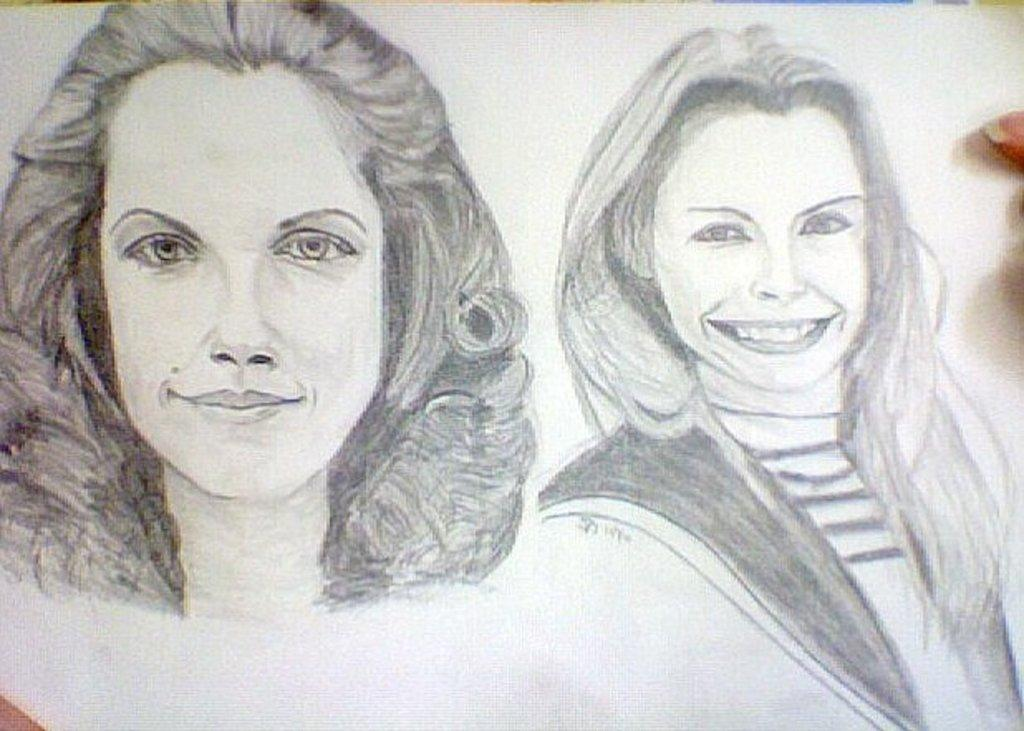What is depicted in the image? There is a drawing of two women in the image. What is the medium of the drawing? The drawing is on a paper. How many children are playing in the drawing? There are no children present in the drawing; it features two women. What type of cloud is depicted in the drawing? There is no cloud depicted in the drawing; it is a drawing of two women on a paper. 